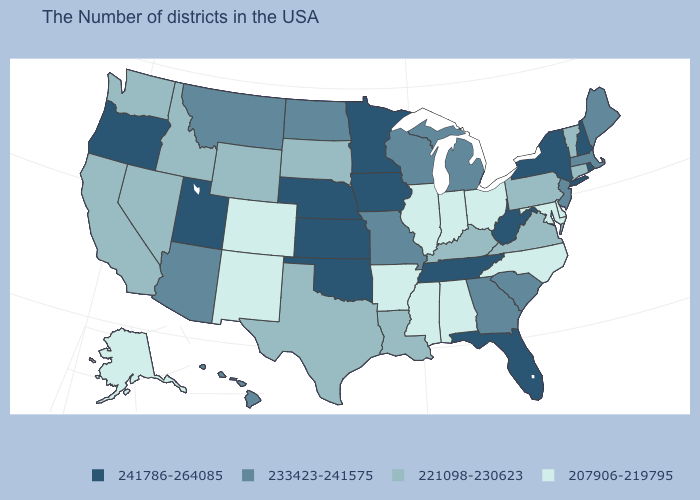Does Texas have the same value as New Hampshire?
Answer briefly. No. Is the legend a continuous bar?
Write a very short answer. No. Name the states that have a value in the range 207906-219795?
Quick response, please. Delaware, Maryland, North Carolina, Ohio, Indiana, Alabama, Illinois, Mississippi, Arkansas, Colorado, New Mexico, Alaska. Which states hav the highest value in the Northeast?
Write a very short answer. Rhode Island, New Hampshire, New York. Which states have the lowest value in the USA?
Be succinct. Delaware, Maryland, North Carolina, Ohio, Indiana, Alabama, Illinois, Mississippi, Arkansas, Colorado, New Mexico, Alaska. What is the highest value in the South ?
Short answer required. 241786-264085. Does the first symbol in the legend represent the smallest category?
Keep it brief. No. Which states have the lowest value in the USA?
Be succinct. Delaware, Maryland, North Carolina, Ohio, Indiana, Alabama, Illinois, Mississippi, Arkansas, Colorado, New Mexico, Alaska. Among the states that border New York , does Pennsylvania have the lowest value?
Quick response, please. Yes. Does Rhode Island have the highest value in the Northeast?
Be succinct. Yes. Among the states that border Nebraska , which have the lowest value?
Be succinct. Colorado. Which states have the lowest value in the USA?
Give a very brief answer. Delaware, Maryland, North Carolina, Ohio, Indiana, Alabama, Illinois, Mississippi, Arkansas, Colorado, New Mexico, Alaska. Name the states that have a value in the range 233423-241575?
Short answer required. Maine, Massachusetts, New Jersey, South Carolina, Georgia, Michigan, Wisconsin, Missouri, North Dakota, Montana, Arizona, Hawaii. Name the states that have a value in the range 233423-241575?
Keep it brief. Maine, Massachusetts, New Jersey, South Carolina, Georgia, Michigan, Wisconsin, Missouri, North Dakota, Montana, Arizona, Hawaii. 